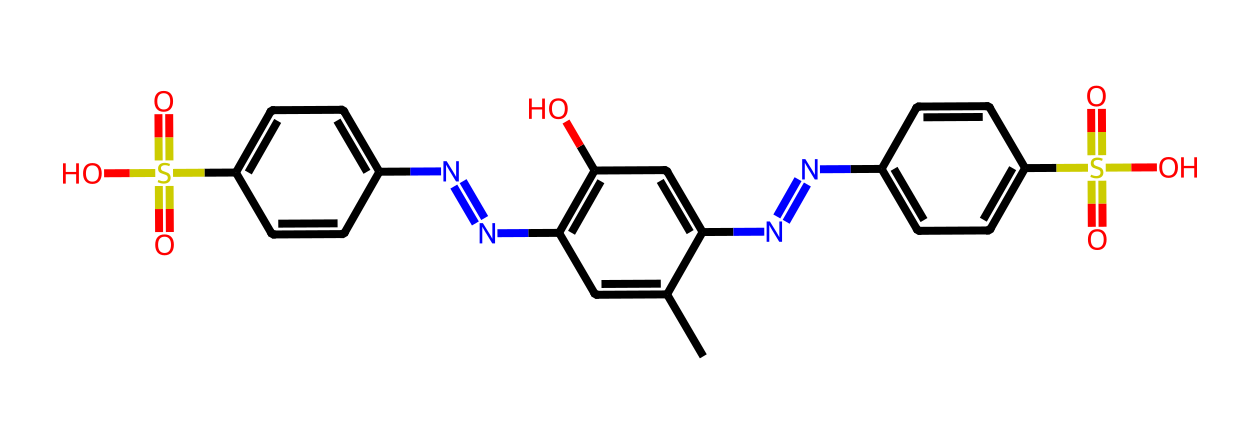What is the total number of nitrogen atoms in this structure? The given SMILES representation contains several 'N' characters, which represent nitrogen atoms. Upon counting, there are four nitrogen atoms depicted in the structure.
Answer: four How many sulfonic acid groups are present in this dye? The structure contains 'S(=O)(=O)O', which corresponds to the sulfonic acid group. There are two instances of this group in the molecule, leading to a total of two sulfonic acid groups.
Answer: two What is the main functional group present in this dye? Analyzing the structure indicates the presence of multiple functional groups, but the presence of both sulfonic acid and hydroxyl groups suggests that the sulfonic acid is the most prominent for dyes, specifically indicated by 'S(=O)(=O)O'.
Answer: sulfonic acid Which atom type appears the most in the molecular structure? By examining the SMILES string and counting the occurrences of each atom type, carbon atoms ('C') are the most frequently occurring, dominating the structure of the dye.
Answer: carbon Is this dye likely to be soluble in water? The presence of sulfonic acid groups typically makes the dye more polar, which in turn enhances its solubility in water, suggesting that this dye is likely to be soluble.
Answer: yes How many carbon atoms are there in total in this dye? The SMILES representation has many 'C' characters indicating carbon atoms. By counting them carefully, there are 18 carbon atoms present in total.
Answer: eighteen 